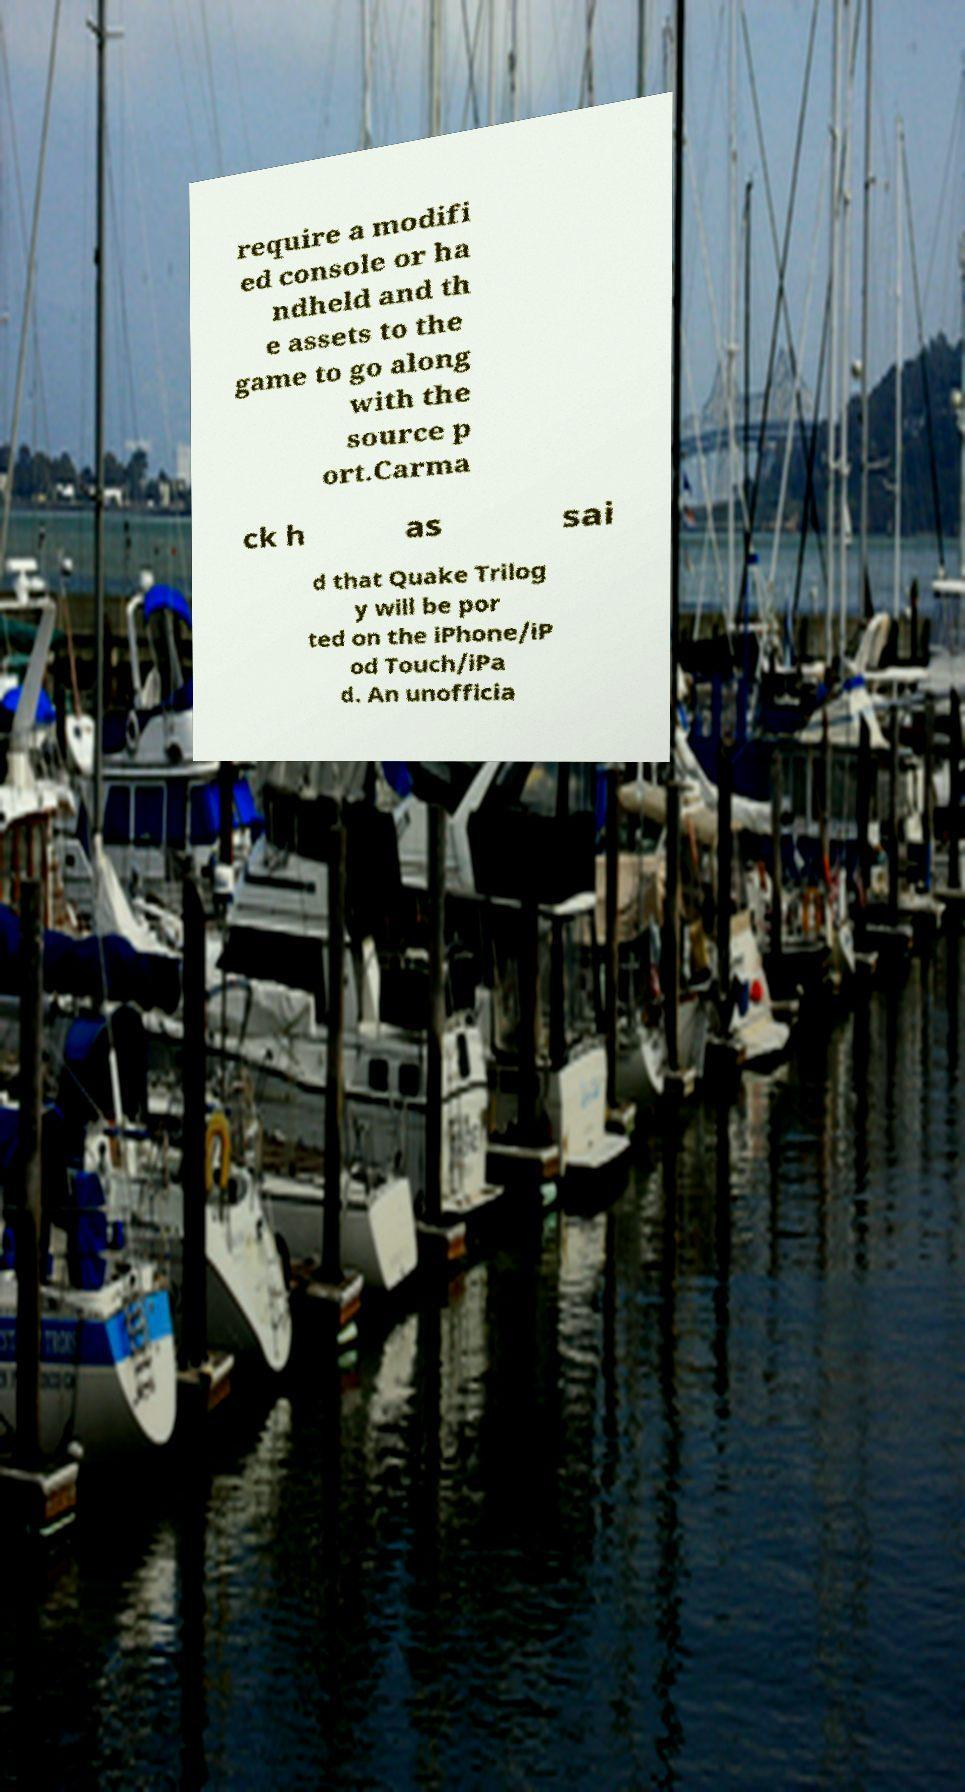For documentation purposes, I need the text within this image transcribed. Could you provide that? require a modifi ed console or ha ndheld and th e assets to the game to go along with the source p ort.Carma ck h as sai d that Quake Trilog y will be por ted on the iPhone/iP od Touch/iPa d. An unofficia 